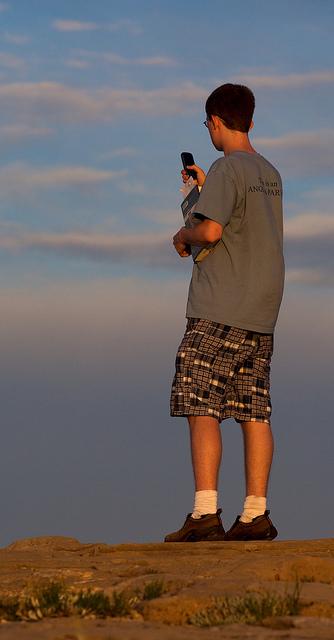Is this man in shape?
Short answer required. Yes. What does the man's short say?
Give a very brief answer. Nothing. Is this man showing off?
Write a very short answer. No. Is this man standing still?
Be succinct. Yes. Is the boy standing on top of a mountain?
Give a very brief answer. Yes. What is the man wearing?
Write a very short answer. Shirt and shorts. Is the man inside or outside?
Write a very short answer. Outside. What is the man holding onto?
Be succinct. Phone. Was is the man doing?
Give a very brief answer. Texting. What color socks is this man wearing?
Answer briefly. White. Is the man throwing something?
Concise answer only. No. What is the man doing?
Concise answer only. Taking picture. 